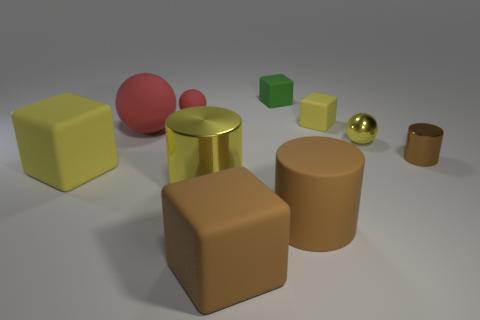Are the small red ball and the small ball in front of the small red matte object made of the same material?
Ensure brevity in your answer.  No. Is the number of brown cylinders that are to the right of the big brown rubber cylinder the same as the number of small metal things that are to the left of the small metallic ball?
Provide a succinct answer. No. There is a yellow cylinder; is its size the same as the yellow matte block behind the tiny brown metal cylinder?
Offer a terse response. No. Are there more small yellow spheres in front of the tiny yellow metallic ball than small gray matte blocks?
Make the answer very short. No. How many yellow metallic cylinders are the same size as the green matte cube?
Your answer should be compact. 0. There is a yellow matte thing behind the large red rubber thing; does it have the same size as the yellow shiny object behind the brown metallic cylinder?
Your answer should be very brief. Yes. Are there more matte cylinders on the right side of the small brown metal thing than tiny brown objects that are in front of the big brown cylinder?
Your answer should be very brief. No. How many large red things have the same shape as the tiny brown metal thing?
Provide a short and direct response. 0. What material is the brown cylinder that is the same size as the brown block?
Your answer should be very brief. Rubber. Are there any purple cylinders that have the same material as the tiny red ball?
Make the answer very short. No. 